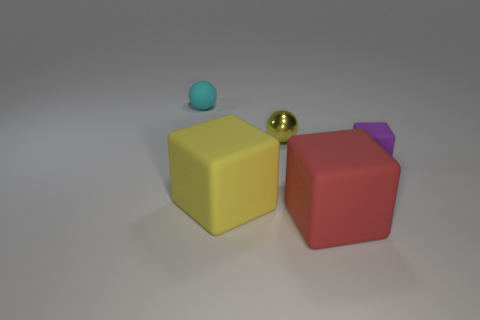Subtract all small purple rubber cubes. How many cubes are left? 2 Subtract all yellow cubes. How many cubes are left? 2 Subtract all blocks. How many objects are left? 2 Add 1 gray objects. How many objects exist? 6 Subtract 2 spheres. How many spheres are left? 0 Subtract all cyan blocks. How many purple balls are left? 0 Subtract all large gray cylinders. Subtract all red cubes. How many objects are left? 4 Add 2 yellow shiny things. How many yellow shiny things are left? 3 Add 1 big matte cubes. How many big matte cubes exist? 3 Subtract 1 red cubes. How many objects are left? 4 